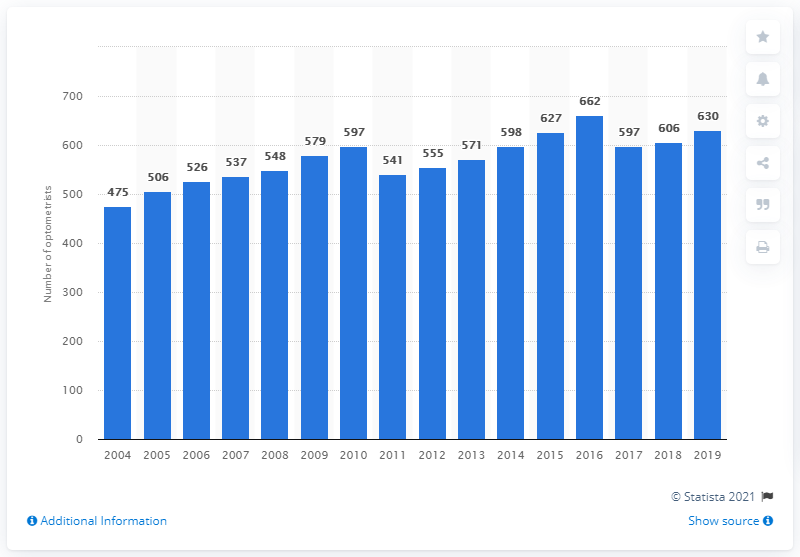Give some essential details in this illustration. There were 630 optometrists in Northern Ireland in 2019. The number of optometrists has generally increased since 2004. 